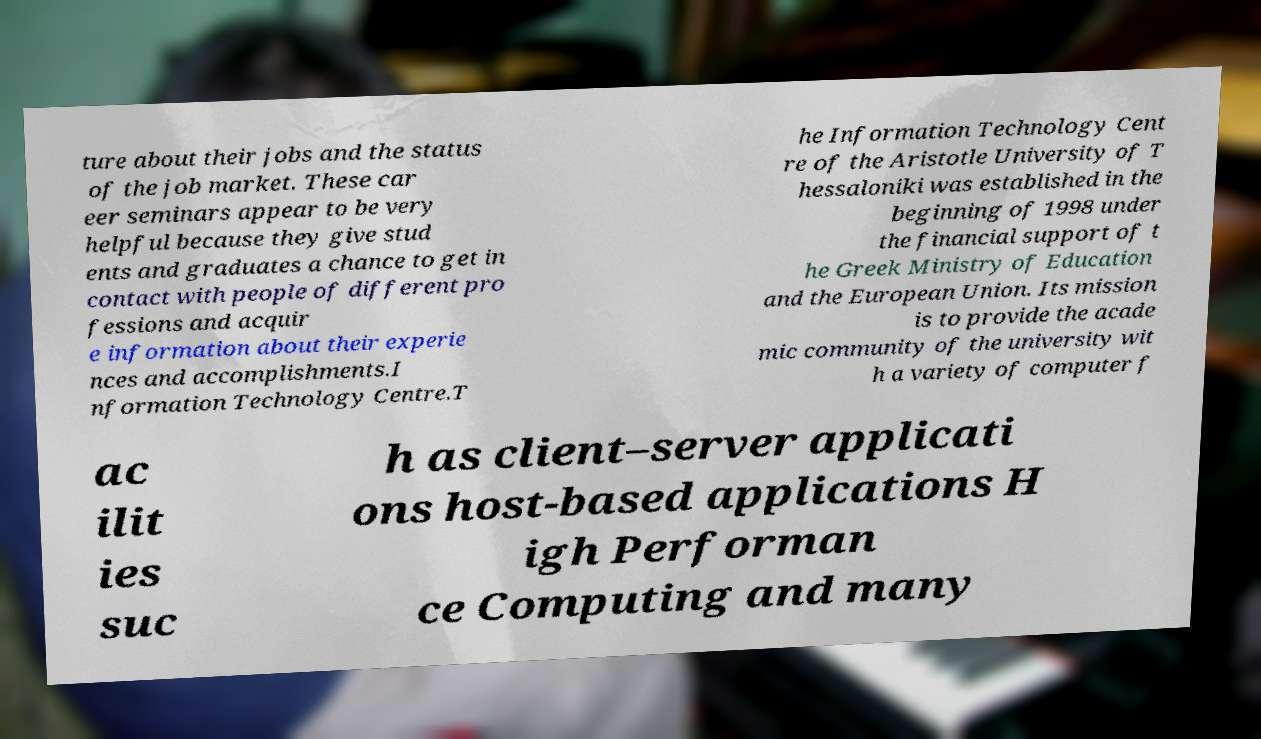Could you extract and type out the text from this image? ture about their jobs and the status of the job market. These car eer seminars appear to be very helpful because they give stud ents and graduates a chance to get in contact with people of different pro fessions and acquir e information about their experie nces and accomplishments.I nformation Technology Centre.T he Information Technology Cent re of the Aristotle University of T hessaloniki was established in the beginning of 1998 under the financial support of t he Greek Ministry of Education and the European Union. Its mission is to provide the acade mic community of the university wit h a variety of computer f ac ilit ies suc h as client–server applicati ons host-based applications H igh Performan ce Computing and many 